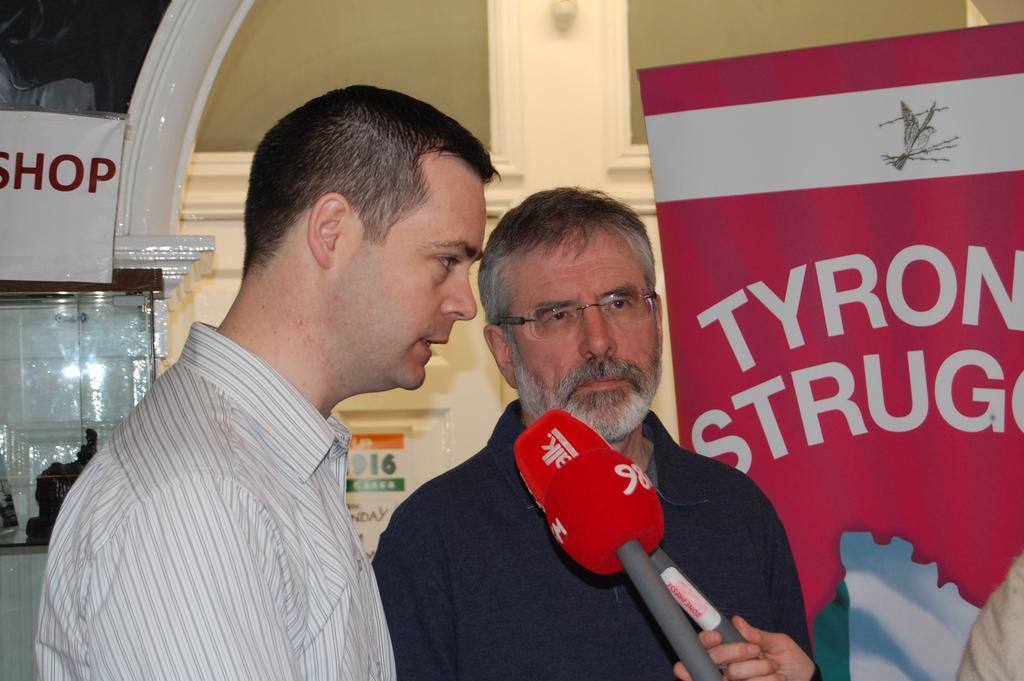Please provide a concise description of this image. In this picture we can see few people, in the middle of the image we can see two men, in front of them we can see microphones, in the background we can see a hoarding and few posters on the wall. 